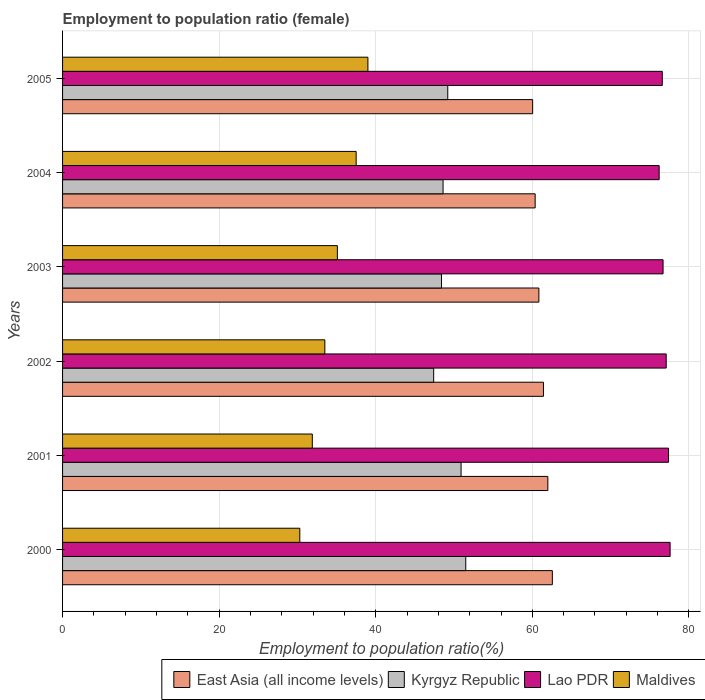How many different coloured bars are there?
Your answer should be compact. 4. How many groups of bars are there?
Make the answer very short. 6. How many bars are there on the 1st tick from the top?
Provide a succinct answer. 4. In how many cases, is the number of bars for a given year not equal to the number of legend labels?
Provide a short and direct response. 0. What is the employment to population ratio in East Asia (all income levels) in 2003?
Make the answer very short. 60.84. Across all years, what is the maximum employment to population ratio in Lao PDR?
Keep it short and to the point. 77.6. Across all years, what is the minimum employment to population ratio in Maldives?
Give a very brief answer. 30.3. In which year was the employment to population ratio in Kyrgyz Republic maximum?
Your answer should be very brief. 2000. What is the total employment to population ratio in East Asia (all income levels) in the graph?
Make the answer very short. 367.2. What is the difference between the employment to population ratio in Lao PDR in 2001 and that in 2004?
Your response must be concise. 1.2. What is the difference between the employment to population ratio in Kyrgyz Republic in 2005 and the employment to population ratio in East Asia (all income levels) in 2002?
Offer a very short reply. -12.22. What is the average employment to population ratio in East Asia (all income levels) per year?
Your answer should be very brief. 61.2. In the year 2000, what is the difference between the employment to population ratio in Lao PDR and employment to population ratio in East Asia (all income levels)?
Your answer should be compact. 15.04. What is the ratio of the employment to population ratio in East Asia (all income levels) in 2001 to that in 2005?
Your answer should be compact. 1.03. What is the difference between the highest and the second highest employment to population ratio in Maldives?
Keep it short and to the point. 1.5. What is the difference between the highest and the lowest employment to population ratio in East Asia (all income levels)?
Provide a succinct answer. 2.52. In how many years, is the employment to population ratio in Maldives greater than the average employment to population ratio in Maldives taken over all years?
Provide a succinct answer. 3. Is the sum of the employment to population ratio in Lao PDR in 2002 and 2004 greater than the maximum employment to population ratio in East Asia (all income levels) across all years?
Offer a very short reply. Yes. Is it the case that in every year, the sum of the employment to population ratio in Kyrgyz Republic and employment to population ratio in Lao PDR is greater than the sum of employment to population ratio in Maldives and employment to population ratio in East Asia (all income levels)?
Make the answer very short. Yes. What does the 3rd bar from the top in 2003 represents?
Keep it short and to the point. Kyrgyz Republic. What does the 3rd bar from the bottom in 2000 represents?
Ensure brevity in your answer.  Lao PDR. How many years are there in the graph?
Give a very brief answer. 6. Does the graph contain any zero values?
Offer a very short reply. No. Does the graph contain grids?
Provide a short and direct response. Yes. How many legend labels are there?
Offer a very short reply. 4. How are the legend labels stacked?
Ensure brevity in your answer.  Horizontal. What is the title of the graph?
Your answer should be very brief. Employment to population ratio (female). What is the Employment to population ratio(%) of East Asia (all income levels) in 2000?
Give a very brief answer. 62.56. What is the Employment to population ratio(%) of Kyrgyz Republic in 2000?
Give a very brief answer. 51.5. What is the Employment to population ratio(%) of Lao PDR in 2000?
Ensure brevity in your answer.  77.6. What is the Employment to population ratio(%) of Maldives in 2000?
Your answer should be very brief. 30.3. What is the Employment to population ratio(%) in East Asia (all income levels) in 2001?
Provide a succinct answer. 61.98. What is the Employment to population ratio(%) of Kyrgyz Republic in 2001?
Make the answer very short. 50.9. What is the Employment to population ratio(%) in Lao PDR in 2001?
Provide a succinct answer. 77.4. What is the Employment to population ratio(%) in Maldives in 2001?
Provide a succinct answer. 31.9. What is the Employment to population ratio(%) of East Asia (all income levels) in 2002?
Your response must be concise. 61.42. What is the Employment to population ratio(%) of Kyrgyz Republic in 2002?
Keep it short and to the point. 47.4. What is the Employment to population ratio(%) of Lao PDR in 2002?
Provide a short and direct response. 77.1. What is the Employment to population ratio(%) in Maldives in 2002?
Ensure brevity in your answer.  33.5. What is the Employment to population ratio(%) of East Asia (all income levels) in 2003?
Offer a very short reply. 60.84. What is the Employment to population ratio(%) of Kyrgyz Republic in 2003?
Your answer should be compact. 48.4. What is the Employment to population ratio(%) in Lao PDR in 2003?
Offer a terse response. 76.7. What is the Employment to population ratio(%) of Maldives in 2003?
Your answer should be very brief. 35.1. What is the Employment to population ratio(%) of East Asia (all income levels) in 2004?
Make the answer very short. 60.36. What is the Employment to population ratio(%) of Kyrgyz Republic in 2004?
Offer a terse response. 48.6. What is the Employment to population ratio(%) of Lao PDR in 2004?
Ensure brevity in your answer.  76.2. What is the Employment to population ratio(%) of Maldives in 2004?
Your answer should be compact. 37.5. What is the Employment to population ratio(%) of East Asia (all income levels) in 2005?
Ensure brevity in your answer.  60.04. What is the Employment to population ratio(%) in Kyrgyz Republic in 2005?
Keep it short and to the point. 49.2. What is the Employment to population ratio(%) of Lao PDR in 2005?
Provide a succinct answer. 76.6. What is the Employment to population ratio(%) in Maldives in 2005?
Your response must be concise. 39. Across all years, what is the maximum Employment to population ratio(%) of East Asia (all income levels)?
Your answer should be very brief. 62.56. Across all years, what is the maximum Employment to population ratio(%) of Kyrgyz Republic?
Your answer should be very brief. 51.5. Across all years, what is the maximum Employment to population ratio(%) of Lao PDR?
Your response must be concise. 77.6. Across all years, what is the maximum Employment to population ratio(%) of Maldives?
Provide a short and direct response. 39. Across all years, what is the minimum Employment to population ratio(%) of East Asia (all income levels)?
Your answer should be very brief. 60.04. Across all years, what is the minimum Employment to population ratio(%) of Kyrgyz Republic?
Offer a terse response. 47.4. Across all years, what is the minimum Employment to population ratio(%) in Lao PDR?
Your answer should be very brief. 76.2. Across all years, what is the minimum Employment to population ratio(%) in Maldives?
Make the answer very short. 30.3. What is the total Employment to population ratio(%) in East Asia (all income levels) in the graph?
Your answer should be compact. 367.2. What is the total Employment to population ratio(%) in Kyrgyz Republic in the graph?
Make the answer very short. 296. What is the total Employment to population ratio(%) of Lao PDR in the graph?
Provide a short and direct response. 461.6. What is the total Employment to population ratio(%) of Maldives in the graph?
Offer a very short reply. 207.3. What is the difference between the Employment to population ratio(%) in East Asia (all income levels) in 2000 and that in 2001?
Your answer should be very brief. 0.57. What is the difference between the Employment to population ratio(%) in East Asia (all income levels) in 2000 and that in 2002?
Your answer should be very brief. 1.14. What is the difference between the Employment to population ratio(%) in Kyrgyz Republic in 2000 and that in 2002?
Make the answer very short. 4.1. What is the difference between the Employment to population ratio(%) in Lao PDR in 2000 and that in 2002?
Your answer should be compact. 0.5. What is the difference between the Employment to population ratio(%) in Maldives in 2000 and that in 2002?
Ensure brevity in your answer.  -3.2. What is the difference between the Employment to population ratio(%) of East Asia (all income levels) in 2000 and that in 2003?
Ensure brevity in your answer.  1.72. What is the difference between the Employment to population ratio(%) of East Asia (all income levels) in 2000 and that in 2004?
Your answer should be compact. 2.2. What is the difference between the Employment to population ratio(%) of Kyrgyz Republic in 2000 and that in 2004?
Your answer should be compact. 2.9. What is the difference between the Employment to population ratio(%) in Lao PDR in 2000 and that in 2004?
Your response must be concise. 1.4. What is the difference between the Employment to population ratio(%) in East Asia (all income levels) in 2000 and that in 2005?
Offer a very short reply. 2.52. What is the difference between the Employment to population ratio(%) in East Asia (all income levels) in 2001 and that in 2002?
Your answer should be very brief. 0.56. What is the difference between the Employment to population ratio(%) of Maldives in 2001 and that in 2002?
Provide a succinct answer. -1.6. What is the difference between the Employment to population ratio(%) of East Asia (all income levels) in 2001 and that in 2003?
Your answer should be very brief. 1.15. What is the difference between the Employment to population ratio(%) in East Asia (all income levels) in 2001 and that in 2004?
Your answer should be very brief. 1.62. What is the difference between the Employment to population ratio(%) of Lao PDR in 2001 and that in 2004?
Provide a short and direct response. 1.2. What is the difference between the Employment to population ratio(%) of Maldives in 2001 and that in 2004?
Ensure brevity in your answer.  -5.6. What is the difference between the Employment to population ratio(%) of East Asia (all income levels) in 2001 and that in 2005?
Your response must be concise. 1.94. What is the difference between the Employment to population ratio(%) in Kyrgyz Republic in 2001 and that in 2005?
Give a very brief answer. 1.7. What is the difference between the Employment to population ratio(%) of East Asia (all income levels) in 2002 and that in 2003?
Keep it short and to the point. 0.58. What is the difference between the Employment to population ratio(%) of Kyrgyz Republic in 2002 and that in 2003?
Your response must be concise. -1. What is the difference between the Employment to population ratio(%) in East Asia (all income levels) in 2002 and that in 2004?
Give a very brief answer. 1.06. What is the difference between the Employment to population ratio(%) of Kyrgyz Republic in 2002 and that in 2004?
Provide a succinct answer. -1.2. What is the difference between the Employment to population ratio(%) in Lao PDR in 2002 and that in 2004?
Provide a succinct answer. 0.9. What is the difference between the Employment to population ratio(%) in East Asia (all income levels) in 2002 and that in 2005?
Ensure brevity in your answer.  1.38. What is the difference between the Employment to population ratio(%) in Kyrgyz Republic in 2002 and that in 2005?
Provide a succinct answer. -1.8. What is the difference between the Employment to population ratio(%) in Lao PDR in 2002 and that in 2005?
Offer a very short reply. 0.5. What is the difference between the Employment to population ratio(%) of East Asia (all income levels) in 2003 and that in 2004?
Ensure brevity in your answer.  0.48. What is the difference between the Employment to population ratio(%) of Lao PDR in 2003 and that in 2004?
Your answer should be compact. 0.5. What is the difference between the Employment to population ratio(%) in Maldives in 2003 and that in 2004?
Offer a very short reply. -2.4. What is the difference between the Employment to population ratio(%) in East Asia (all income levels) in 2003 and that in 2005?
Offer a very short reply. 0.8. What is the difference between the Employment to population ratio(%) of Kyrgyz Republic in 2003 and that in 2005?
Your answer should be compact. -0.8. What is the difference between the Employment to population ratio(%) in Lao PDR in 2003 and that in 2005?
Make the answer very short. 0.1. What is the difference between the Employment to population ratio(%) of Maldives in 2003 and that in 2005?
Your response must be concise. -3.9. What is the difference between the Employment to population ratio(%) of East Asia (all income levels) in 2004 and that in 2005?
Your response must be concise. 0.32. What is the difference between the Employment to population ratio(%) of Maldives in 2004 and that in 2005?
Your response must be concise. -1.5. What is the difference between the Employment to population ratio(%) in East Asia (all income levels) in 2000 and the Employment to population ratio(%) in Kyrgyz Republic in 2001?
Provide a succinct answer. 11.66. What is the difference between the Employment to population ratio(%) in East Asia (all income levels) in 2000 and the Employment to population ratio(%) in Lao PDR in 2001?
Offer a terse response. -14.84. What is the difference between the Employment to population ratio(%) in East Asia (all income levels) in 2000 and the Employment to population ratio(%) in Maldives in 2001?
Your answer should be very brief. 30.66. What is the difference between the Employment to population ratio(%) in Kyrgyz Republic in 2000 and the Employment to population ratio(%) in Lao PDR in 2001?
Offer a very short reply. -25.9. What is the difference between the Employment to population ratio(%) of Kyrgyz Republic in 2000 and the Employment to population ratio(%) of Maldives in 2001?
Offer a terse response. 19.6. What is the difference between the Employment to population ratio(%) in Lao PDR in 2000 and the Employment to population ratio(%) in Maldives in 2001?
Give a very brief answer. 45.7. What is the difference between the Employment to population ratio(%) of East Asia (all income levels) in 2000 and the Employment to population ratio(%) of Kyrgyz Republic in 2002?
Offer a terse response. 15.16. What is the difference between the Employment to population ratio(%) in East Asia (all income levels) in 2000 and the Employment to population ratio(%) in Lao PDR in 2002?
Offer a terse response. -14.54. What is the difference between the Employment to population ratio(%) of East Asia (all income levels) in 2000 and the Employment to population ratio(%) of Maldives in 2002?
Offer a terse response. 29.06. What is the difference between the Employment to population ratio(%) of Kyrgyz Republic in 2000 and the Employment to population ratio(%) of Lao PDR in 2002?
Make the answer very short. -25.6. What is the difference between the Employment to population ratio(%) in Kyrgyz Republic in 2000 and the Employment to population ratio(%) in Maldives in 2002?
Your response must be concise. 18. What is the difference between the Employment to population ratio(%) in Lao PDR in 2000 and the Employment to population ratio(%) in Maldives in 2002?
Offer a very short reply. 44.1. What is the difference between the Employment to population ratio(%) of East Asia (all income levels) in 2000 and the Employment to population ratio(%) of Kyrgyz Republic in 2003?
Your answer should be compact. 14.16. What is the difference between the Employment to population ratio(%) of East Asia (all income levels) in 2000 and the Employment to population ratio(%) of Lao PDR in 2003?
Your answer should be very brief. -14.14. What is the difference between the Employment to population ratio(%) of East Asia (all income levels) in 2000 and the Employment to population ratio(%) of Maldives in 2003?
Offer a very short reply. 27.46. What is the difference between the Employment to population ratio(%) in Kyrgyz Republic in 2000 and the Employment to population ratio(%) in Lao PDR in 2003?
Your answer should be very brief. -25.2. What is the difference between the Employment to population ratio(%) of Kyrgyz Republic in 2000 and the Employment to population ratio(%) of Maldives in 2003?
Your response must be concise. 16.4. What is the difference between the Employment to population ratio(%) in Lao PDR in 2000 and the Employment to population ratio(%) in Maldives in 2003?
Offer a terse response. 42.5. What is the difference between the Employment to population ratio(%) of East Asia (all income levels) in 2000 and the Employment to population ratio(%) of Kyrgyz Republic in 2004?
Ensure brevity in your answer.  13.96. What is the difference between the Employment to population ratio(%) in East Asia (all income levels) in 2000 and the Employment to population ratio(%) in Lao PDR in 2004?
Offer a terse response. -13.64. What is the difference between the Employment to population ratio(%) in East Asia (all income levels) in 2000 and the Employment to population ratio(%) in Maldives in 2004?
Keep it short and to the point. 25.06. What is the difference between the Employment to population ratio(%) in Kyrgyz Republic in 2000 and the Employment to population ratio(%) in Lao PDR in 2004?
Give a very brief answer. -24.7. What is the difference between the Employment to population ratio(%) in Kyrgyz Republic in 2000 and the Employment to population ratio(%) in Maldives in 2004?
Provide a succinct answer. 14. What is the difference between the Employment to population ratio(%) in Lao PDR in 2000 and the Employment to population ratio(%) in Maldives in 2004?
Provide a short and direct response. 40.1. What is the difference between the Employment to population ratio(%) in East Asia (all income levels) in 2000 and the Employment to population ratio(%) in Kyrgyz Republic in 2005?
Give a very brief answer. 13.36. What is the difference between the Employment to population ratio(%) of East Asia (all income levels) in 2000 and the Employment to population ratio(%) of Lao PDR in 2005?
Offer a terse response. -14.04. What is the difference between the Employment to population ratio(%) of East Asia (all income levels) in 2000 and the Employment to population ratio(%) of Maldives in 2005?
Your response must be concise. 23.56. What is the difference between the Employment to population ratio(%) in Kyrgyz Republic in 2000 and the Employment to population ratio(%) in Lao PDR in 2005?
Your answer should be very brief. -25.1. What is the difference between the Employment to population ratio(%) in Kyrgyz Republic in 2000 and the Employment to population ratio(%) in Maldives in 2005?
Give a very brief answer. 12.5. What is the difference between the Employment to population ratio(%) of Lao PDR in 2000 and the Employment to population ratio(%) of Maldives in 2005?
Your answer should be very brief. 38.6. What is the difference between the Employment to population ratio(%) of East Asia (all income levels) in 2001 and the Employment to population ratio(%) of Kyrgyz Republic in 2002?
Your response must be concise. 14.58. What is the difference between the Employment to population ratio(%) in East Asia (all income levels) in 2001 and the Employment to population ratio(%) in Lao PDR in 2002?
Your answer should be very brief. -15.12. What is the difference between the Employment to population ratio(%) in East Asia (all income levels) in 2001 and the Employment to population ratio(%) in Maldives in 2002?
Keep it short and to the point. 28.48. What is the difference between the Employment to population ratio(%) in Kyrgyz Republic in 2001 and the Employment to population ratio(%) in Lao PDR in 2002?
Your answer should be very brief. -26.2. What is the difference between the Employment to population ratio(%) in Lao PDR in 2001 and the Employment to population ratio(%) in Maldives in 2002?
Offer a very short reply. 43.9. What is the difference between the Employment to population ratio(%) of East Asia (all income levels) in 2001 and the Employment to population ratio(%) of Kyrgyz Republic in 2003?
Give a very brief answer. 13.58. What is the difference between the Employment to population ratio(%) of East Asia (all income levels) in 2001 and the Employment to population ratio(%) of Lao PDR in 2003?
Your response must be concise. -14.72. What is the difference between the Employment to population ratio(%) of East Asia (all income levels) in 2001 and the Employment to population ratio(%) of Maldives in 2003?
Your answer should be very brief. 26.88. What is the difference between the Employment to population ratio(%) in Kyrgyz Republic in 2001 and the Employment to population ratio(%) in Lao PDR in 2003?
Give a very brief answer. -25.8. What is the difference between the Employment to population ratio(%) of Lao PDR in 2001 and the Employment to population ratio(%) of Maldives in 2003?
Offer a very short reply. 42.3. What is the difference between the Employment to population ratio(%) of East Asia (all income levels) in 2001 and the Employment to population ratio(%) of Kyrgyz Republic in 2004?
Your answer should be compact. 13.38. What is the difference between the Employment to population ratio(%) of East Asia (all income levels) in 2001 and the Employment to population ratio(%) of Lao PDR in 2004?
Offer a terse response. -14.22. What is the difference between the Employment to population ratio(%) of East Asia (all income levels) in 2001 and the Employment to population ratio(%) of Maldives in 2004?
Your answer should be very brief. 24.48. What is the difference between the Employment to population ratio(%) of Kyrgyz Republic in 2001 and the Employment to population ratio(%) of Lao PDR in 2004?
Your answer should be compact. -25.3. What is the difference between the Employment to population ratio(%) of Kyrgyz Republic in 2001 and the Employment to population ratio(%) of Maldives in 2004?
Offer a very short reply. 13.4. What is the difference between the Employment to population ratio(%) of Lao PDR in 2001 and the Employment to population ratio(%) of Maldives in 2004?
Offer a very short reply. 39.9. What is the difference between the Employment to population ratio(%) in East Asia (all income levels) in 2001 and the Employment to population ratio(%) in Kyrgyz Republic in 2005?
Ensure brevity in your answer.  12.78. What is the difference between the Employment to population ratio(%) of East Asia (all income levels) in 2001 and the Employment to population ratio(%) of Lao PDR in 2005?
Offer a very short reply. -14.62. What is the difference between the Employment to population ratio(%) of East Asia (all income levels) in 2001 and the Employment to population ratio(%) of Maldives in 2005?
Provide a succinct answer. 22.98. What is the difference between the Employment to population ratio(%) in Kyrgyz Republic in 2001 and the Employment to population ratio(%) in Lao PDR in 2005?
Your answer should be very brief. -25.7. What is the difference between the Employment to population ratio(%) in Kyrgyz Republic in 2001 and the Employment to population ratio(%) in Maldives in 2005?
Your answer should be compact. 11.9. What is the difference between the Employment to population ratio(%) in Lao PDR in 2001 and the Employment to population ratio(%) in Maldives in 2005?
Your response must be concise. 38.4. What is the difference between the Employment to population ratio(%) in East Asia (all income levels) in 2002 and the Employment to population ratio(%) in Kyrgyz Republic in 2003?
Keep it short and to the point. 13.02. What is the difference between the Employment to population ratio(%) of East Asia (all income levels) in 2002 and the Employment to population ratio(%) of Lao PDR in 2003?
Provide a short and direct response. -15.28. What is the difference between the Employment to population ratio(%) in East Asia (all income levels) in 2002 and the Employment to population ratio(%) in Maldives in 2003?
Keep it short and to the point. 26.32. What is the difference between the Employment to population ratio(%) in Kyrgyz Republic in 2002 and the Employment to population ratio(%) in Lao PDR in 2003?
Offer a terse response. -29.3. What is the difference between the Employment to population ratio(%) of Kyrgyz Republic in 2002 and the Employment to population ratio(%) of Maldives in 2003?
Provide a succinct answer. 12.3. What is the difference between the Employment to population ratio(%) of East Asia (all income levels) in 2002 and the Employment to population ratio(%) of Kyrgyz Republic in 2004?
Provide a short and direct response. 12.82. What is the difference between the Employment to population ratio(%) of East Asia (all income levels) in 2002 and the Employment to population ratio(%) of Lao PDR in 2004?
Give a very brief answer. -14.78. What is the difference between the Employment to population ratio(%) in East Asia (all income levels) in 2002 and the Employment to population ratio(%) in Maldives in 2004?
Give a very brief answer. 23.92. What is the difference between the Employment to population ratio(%) in Kyrgyz Republic in 2002 and the Employment to population ratio(%) in Lao PDR in 2004?
Offer a terse response. -28.8. What is the difference between the Employment to population ratio(%) in Lao PDR in 2002 and the Employment to population ratio(%) in Maldives in 2004?
Your answer should be compact. 39.6. What is the difference between the Employment to population ratio(%) of East Asia (all income levels) in 2002 and the Employment to population ratio(%) of Kyrgyz Republic in 2005?
Provide a succinct answer. 12.22. What is the difference between the Employment to population ratio(%) in East Asia (all income levels) in 2002 and the Employment to population ratio(%) in Lao PDR in 2005?
Ensure brevity in your answer.  -15.18. What is the difference between the Employment to population ratio(%) in East Asia (all income levels) in 2002 and the Employment to population ratio(%) in Maldives in 2005?
Offer a terse response. 22.42. What is the difference between the Employment to population ratio(%) of Kyrgyz Republic in 2002 and the Employment to population ratio(%) of Lao PDR in 2005?
Offer a very short reply. -29.2. What is the difference between the Employment to population ratio(%) in Lao PDR in 2002 and the Employment to population ratio(%) in Maldives in 2005?
Offer a very short reply. 38.1. What is the difference between the Employment to population ratio(%) in East Asia (all income levels) in 2003 and the Employment to population ratio(%) in Kyrgyz Republic in 2004?
Ensure brevity in your answer.  12.24. What is the difference between the Employment to population ratio(%) in East Asia (all income levels) in 2003 and the Employment to population ratio(%) in Lao PDR in 2004?
Give a very brief answer. -15.36. What is the difference between the Employment to population ratio(%) of East Asia (all income levels) in 2003 and the Employment to population ratio(%) of Maldives in 2004?
Offer a very short reply. 23.34. What is the difference between the Employment to population ratio(%) in Kyrgyz Republic in 2003 and the Employment to population ratio(%) in Lao PDR in 2004?
Give a very brief answer. -27.8. What is the difference between the Employment to population ratio(%) of Lao PDR in 2003 and the Employment to population ratio(%) of Maldives in 2004?
Your response must be concise. 39.2. What is the difference between the Employment to population ratio(%) of East Asia (all income levels) in 2003 and the Employment to population ratio(%) of Kyrgyz Republic in 2005?
Provide a short and direct response. 11.64. What is the difference between the Employment to population ratio(%) of East Asia (all income levels) in 2003 and the Employment to population ratio(%) of Lao PDR in 2005?
Make the answer very short. -15.76. What is the difference between the Employment to population ratio(%) of East Asia (all income levels) in 2003 and the Employment to population ratio(%) of Maldives in 2005?
Ensure brevity in your answer.  21.84. What is the difference between the Employment to population ratio(%) of Kyrgyz Republic in 2003 and the Employment to population ratio(%) of Lao PDR in 2005?
Your response must be concise. -28.2. What is the difference between the Employment to population ratio(%) in Lao PDR in 2003 and the Employment to population ratio(%) in Maldives in 2005?
Give a very brief answer. 37.7. What is the difference between the Employment to population ratio(%) in East Asia (all income levels) in 2004 and the Employment to population ratio(%) in Kyrgyz Republic in 2005?
Keep it short and to the point. 11.16. What is the difference between the Employment to population ratio(%) in East Asia (all income levels) in 2004 and the Employment to population ratio(%) in Lao PDR in 2005?
Keep it short and to the point. -16.24. What is the difference between the Employment to population ratio(%) in East Asia (all income levels) in 2004 and the Employment to population ratio(%) in Maldives in 2005?
Ensure brevity in your answer.  21.36. What is the difference between the Employment to population ratio(%) in Lao PDR in 2004 and the Employment to population ratio(%) in Maldives in 2005?
Make the answer very short. 37.2. What is the average Employment to population ratio(%) in East Asia (all income levels) per year?
Your answer should be very brief. 61.2. What is the average Employment to population ratio(%) in Kyrgyz Republic per year?
Your answer should be very brief. 49.33. What is the average Employment to population ratio(%) of Lao PDR per year?
Provide a short and direct response. 76.93. What is the average Employment to population ratio(%) of Maldives per year?
Keep it short and to the point. 34.55. In the year 2000, what is the difference between the Employment to population ratio(%) in East Asia (all income levels) and Employment to population ratio(%) in Kyrgyz Republic?
Your answer should be very brief. 11.06. In the year 2000, what is the difference between the Employment to population ratio(%) in East Asia (all income levels) and Employment to population ratio(%) in Lao PDR?
Give a very brief answer. -15.04. In the year 2000, what is the difference between the Employment to population ratio(%) in East Asia (all income levels) and Employment to population ratio(%) in Maldives?
Your answer should be compact. 32.26. In the year 2000, what is the difference between the Employment to population ratio(%) in Kyrgyz Republic and Employment to population ratio(%) in Lao PDR?
Give a very brief answer. -26.1. In the year 2000, what is the difference between the Employment to population ratio(%) of Kyrgyz Republic and Employment to population ratio(%) of Maldives?
Provide a succinct answer. 21.2. In the year 2000, what is the difference between the Employment to population ratio(%) of Lao PDR and Employment to population ratio(%) of Maldives?
Provide a succinct answer. 47.3. In the year 2001, what is the difference between the Employment to population ratio(%) of East Asia (all income levels) and Employment to population ratio(%) of Kyrgyz Republic?
Offer a very short reply. 11.08. In the year 2001, what is the difference between the Employment to population ratio(%) of East Asia (all income levels) and Employment to population ratio(%) of Lao PDR?
Your answer should be very brief. -15.42. In the year 2001, what is the difference between the Employment to population ratio(%) of East Asia (all income levels) and Employment to population ratio(%) of Maldives?
Provide a short and direct response. 30.08. In the year 2001, what is the difference between the Employment to population ratio(%) of Kyrgyz Republic and Employment to population ratio(%) of Lao PDR?
Give a very brief answer. -26.5. In the year 2001, what is the difference between the Employment to population ratio(%) in Lao PDR and Employment to population ratio(%) in Maldives?
Provide a short and direct response. 45.5. In the year 2002, what is the difference between the Employment to population ratio(%) in East Asia (all income levels) and Employment to population ratio(%) in Kyrgyz Republic?
Offer a terse response. 14.02. In the year 2002, what is the difference between the Employment to population ratio(%) of East Asia (all income levels) and Employment to population ratio(%) of Lao PDR?
Your answer should be compact. -15.68. In the year 2002, what is the difference between the Employment to population ratio(%) of East Asia (all income levels) and Employment to population ratio(%) of Maldives?
Make the answer very short. 27.92. In the year 2002, what is the difference between the Employment to population ratio(%) in Kyrgyz Republic and Employment to population ratio(%) in Lao PDR?
Your answer should be very brief. -29.7. In the year 2002, what is the difference between the Employment to population ratio(%) of Kyrgyz Republic and Employment to population ratio(%) of Maldives?
Make the answer very short. 13.9. In the year 2002, what is the difference between the Employment to population ratio(%) of Lao PDR and Employment to population ratio(%) of Maldives?
Your answer should be very brief. 43.6. In the year 2003, what is the difference between the Employment to population ratio(%) in East Asia (all income levels) and Employment to population ratio(%) in Kyrgyz Republic?
Your answer should be very brief. 12.44. In the year 2003, what is the difference between the Employment to population ratio(%) in East Asia (all income levels) and Employment to population ratio(%) in Lao PDR?
Offer a very short reply. -15.86. In the year 2003, what is the difference between the Employment to population ratio(%) of East Asia (all income levels) and Employment to population ratio(%) of Maldives?
Your response must be concise. 25.74. In the year 2003, what is the difference between the Employment to population ratio(%) in Kyrgyz Republic and Employment to population ratio(%) in Lao PDR?
Keep it short and to the point. -28.3. In the year 2003, what is the difference between the Employment to population ratio(%) in Kyrgyz Republic and Employment to population ratio(%) in Maldives?
Provide a short and direct response. 13.3. In the year 2003, what is the difference between the Employment to population ratio(%) of Lao PDR and Employment to population ratio(%) of Maldives?
Make the answer very short. 41.6. In the year 2004, what is the difference between the Employment to population ratio(%) in East Asia (all income levels) and Employment to population ratio(%) in Kyrgyz Republic?
Your answer should be compact. 11.76. In the year 2004, what is the difference between the Employment to population ratio(%) of East Asia (all income levels) and Employment to population ratio(%) of Lao PDR?
Your answer should be very brief. -15.84. In the year 2004, what is the difference between the Employment to population ratio(%) of East Asia (all income levels) and Employment to population ratio(%) of Maldives?
Keep it short and to the point. 22.86. In the year 2004, what is the difference between the Employment to population ratio(%) in Kyrgyz Republic and Employment to population ratio(%) in Lao PDR?
Offer a terse response. -27.6. In the year 2004, what is the difference between the Employment to population ratio(%) of Kyrgyz Republic and Employment to population ratio(%) of Maldives?
Make the answer very short. 11.1. In the year 2004, what is the difference between the Employment to population ratio(%) in Lao PDR and Employment to population ratio(%) in Maldives?
Provide a short and direct response. 38.7. In the year 2005, what is the difference between the Employment to population ratio(%) in East Asia (all income levels) and Employment to population ratio(%) in Kyrgyz Republic?
Your response must be concise. 10.84. In the year 2005, what is the difference between the Employment to population ratio(%) of East Asia (all income levels) and Employment to population ratio(%) of Lao PDR?
Give a very brief answer. -16.56. In the year 2005, what is the difference between the Employment to population ratio(%) in East Asia (all income levels) and Employment to population ratio(%) in Maldives?
Provide a short and direct response. 21.04. In the year 2005, what is the difference between the Employment to population ratio(%) of Kyrgyz Republic and Employment to population ratio(%) of Lao PDR?
Provide a short and direct response. -27.4. In the year 2005, what is the difference between the Employment to population ratio(%) of Lao PDR and Employment to population ratio(%) of Maldives?
Ensure brevity in your answer.  37.6. What is the ratio of the Employment to population ratio(%) in East Asia (all income levels) in 2000 to that in 2001?
Give a very brief answer. 1.01. What is the ratio of the Employment to population ratio(%) in Kyrgyz Republic in 2000 to that in 2001?
Ensure brevity in your answer.  1.01. What is the ratio of the Employment to population ratio(%) in Maldives in 2000 to that in 2001?
Make the answer very short. 0.95. What is the ratio of the Employment to population ratio(%) of East Asia (all income levels) in 2000 to that in 2002?
Provide a short and direct response. 1.02. What is the ratio of the Employment to population ratio(%) in Kyrgyz Republic in 2000 to that in 2002?
Provide a short and direct response. 1.09. What is the ratio of the Employment to population ratio(%) of Maldives in 2000 to that in 2002?
Make the answer very short. 0.9. What is the ratio of the Employment to population ratio(%) of East Asia (all income levels) in 2000 to that in 2003?
Offer a terse response. 1.03. What is the ratio of the Employment to population ratio(%) of Kyrgyz Republic in 2000 to that in 2003?
Provide a succinct answer. 1.06. What is the ratio of the Employment to population ratio(%) in Lao PDR in 2000 to that in 2003?
Your answer should be compact. 1.01. What is the ratio of the Employment to population ratio(%) in Maldives in 2000 to that in 2003?
Your answer should be very brief. 0.86. What is the ratio of the Employment to population ratio(%) in East Asia (all income levels) in 2000 to that in 2004?
Ensure brevity in your answer.  1.04. What is the ratio of the Employment to population ratio(%) of Kyrgyz Republic in 2000 to that in 2004?
Ensure brevity in your answer.  1.06. What is the ratio of the Employment to population ratio(%) in Lao PDR in 2000 to that in 2004?
Give a very brief answer. 1.02. What is the ratio of the Employment to population ratio(%) in Maldives in 2000 to that in 2004?
Your answer should be compact. 0.81. What is the ratio of the Employment to population ratio(%) in East Asia (all income levels) in 2000 to that in 2005?
Make the answer very short. 1.04. What is the ratio of the Employment to population ratio(%) of Kyrgyz Republic in 2000 to that in 2005?
Offer a very short reply. 1.05. What is the ratio of the Employment to population ratio(%) in Lao PDR in 2000 to that in 2005?
Provide a short and direct response. 1.01. What is the ratio of the Employment to population ratio(%) of Maldives in 2000 to that in 2005?
Provide a short and direct response. 0.78. What is the ratio of the Employment to population ratio(%) in East Asia (all income levels) in 2001 to that in 2002?
Provide a succinct answer. 1.01. What is the ratio of the Employment to population ratio(%) in Kyrgyz Republic in 2001 to that in 2002?
Your answer should be compact. 1.07. What is the ratio of the Employment to population ratio(%) of Maldives in 2001 to that in 2002?
Provide a short and direct response. 0.95. What is the ratio of the Employment to population ratio(%) of East Asia (all income levels) in 2001 to that in 2003?
Your answer should be compact. 1.02. What is the ratio of the Employment to population ratio(%) in Kyrgyz Republic in 2001 to that in 2003?
Provide a short and direct response. 1.05. What is the ratio of the Employment to population ratio(%) of Lao PDR in 2001 to that in 2003?
Make the answer very short. 1.01. What is the ratio of the Employment to population ratio(%) of Maldives in 2001 to that in 2003?
Ensure brevity in your answer.  0.91. What is the ratio of the Employment to population ratio(%) of East Asia (all income levels) in 2001 to that in 2004?
Your answer should be very brief. 1.03. What is the ratio of the Employment to population ratio(%) of Kyrgyz Republic in 2001 to that in 2004?
Ensure brevity in your answer.  1.05. What is the ratio of the Employment to population ratio(%) in Lao PDR in 2001 to that in 2004?
Offer a terse response. 1.02. What is the ratio of the Employment to population ratio(%) in Maldives in 2001 to that in 2004?
Offer a terse response. 0.85. What is the ratio of the Employment to population ratio(%) in East Asia (all income levels) in 2001 to that in 2005?
Your answer should be compact. 1.03. What is the ratio of the Employment to population ratio(%) in Kyrgyz Republic in 2001 to that in 2005?
Provide a succinct answer. 1.03. What is the ratio of the Employment to population ratio(%) in Lao PDR in 2001 to that in 2005?
Keep it short and to the point. 1.01. What is the ratio of the Employment to population ratio(%) of Maldives in 2001 to that in 2005?
Keep it short and to the point. 0.82. What is the ratio of the Employment to population ratio(%) of East Asia (all income levels) in 2002 to that in 2003?
Provide a short and direct response. 1.01. What is the ratio of the Employment to population ratio(%) of Kyrgyz Republic in 2002 to that in 2003?
Ensure brevity in your answer.  0.98. What is the ratio of the Employment to population ratio(%) of Lao PDR in 2002 to that in 2003?
Your answer should be very brief. 1.01. What is the ratio of the Employment to population ratio(%) of Maldives in 2002 to that in 2003?
Give a very brief answer. 0.95. What is the ratio of the Employment to population ratio(%) in East Asia (all income levels) in 2002 to that in 2004?
Keep it short and to the point. 1.02. What is the ratio of the Employment to population ratio(%) of Kyrgyz Republic in 2002 to that in 2004?
Offer a terse response. 0.98. What is the ratio of the Employment to population ratio(%) in Lao PDR in 2002 to that in 2004?
Make the answer very short. 1.01. What is the ratio of the Employment to population ratio(%) of Maldives in 2002 to that in 2004?
Offer a very short reply. 0.89. What is the ratio of the Employment to population ratio(%) of East Asia (all income levels) in 2002 to that in 2005?
Keep it short and to the point. 1.02. What is the ratio of the Employment to population ratio(%) of Kyrgyz Republic in 2002 to that in 2005?
Give a very brief answer. 0.96. What is the ratio of the Employment to population ratio(%) of Maldives in 2002 to that in 2005?
Offer a very short reply. 0.86. What is the ratio of the Employment to population ratio(%) in East Asia (all income levels) in 2003 to that in 2004?
Ensure brevity in your answer.  1.01. What is the ratio of the Employment to population ratio(%) in Kyrgyz Republic in 2003 to that in 2004?
Offer a terse response. 1. What is the ratio of the Employment to population ratio(%) of Lao PDR in 2003 to that in 2004?
Provide a succinct answer. 1.01. What is the ratio of the Employment to population ratio(%) in Maldives in 2003 to that in 2004?
Your response must be concise. 0.94. What is the ratio of the Employment to population ratio(%) in East Asia (all income levels) in 2003 to that in 2005?
Make the answer very short. 1.01. What is the ratio of the Employment to population ratio(%) of Kyrgyz Republic in 2003 to that in 2005?
Offer a terse response. 0.98. What is the ratio of the Employment to population ratio(%) of Maldives in 2003 to that in 2005?
Offer a very short reply. 0.9. What is the ratio of the Employment to population ratio(%) in Kyrgyz Republic in 2004 to that in 2005?
Provide a succinct answer. 0.99. What is the ratio of the Employment to population ratio(%) of Maldives in 2004 to that in 2005?
Provide a short and direct response. 0.96. What is the difference between the highest and the second highest Employment to population ratio(%) in East Asia (all income levels)?
Give a very brief answer. 0.57. What is the difference between the highest and the second highest Employment to population ratio(%) of Kyrgyz Republic?
Provide a succinct answer. 0.6. What is the difference between the highest and the second highest Employment to population ratio(%) in Lao PDR?
Offer a very short reply. 0.2. What is the difference between the highest and the lowest Employment to population ratio(%) in East Asia (all income levels)?
Keep it short and to the point. 2.52. What is the difference between the highest and the lowest Employment to population ratio(%) of Lao PDR?
Ensure brevity in your answer.  1.4. What is the difference between the highest and the lowest Employment to population ratio(%) in Maldives?
Provide a succinct answer. 8.7. 